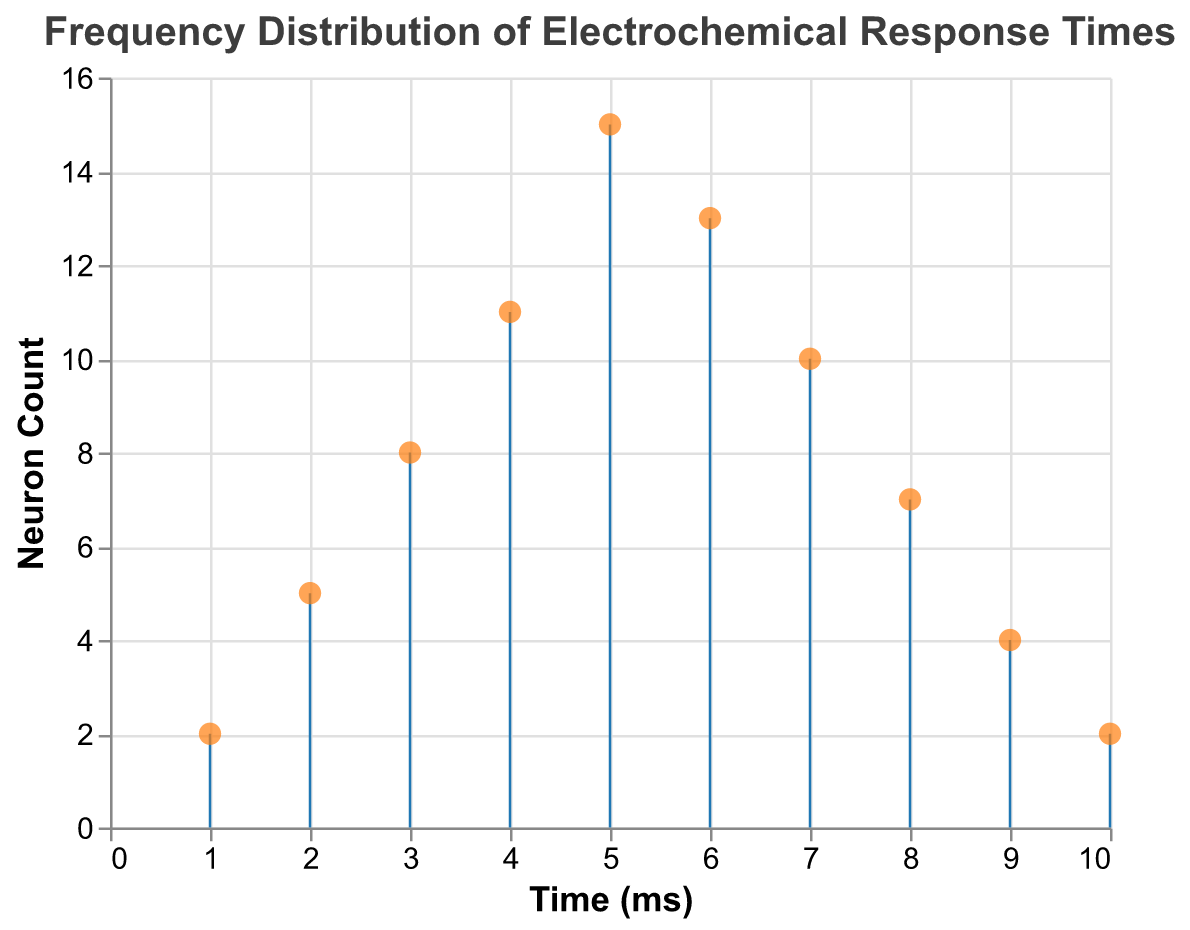What is the title of the plot? The title of the plot is prominently displayed at the top and reads "Frequency Distribution of Electrochemical Response Times".
Answer: Frequency Distribution of Electrochemical Response Times How many data points are plotted? By counting the data points represented by the colored markers on the plot, there are ten data points.
Answer: Ten What is the electrochemical response time with the highest neuron count? The data point with the highest count has a value of 15 neurons, which corresponds to a time of 5 ms.
Answer: 5 ms How does the neuron count change from 4 ms to 5 ms? At 4 ms, the neuron count is 11, and it increases to 15 at 5 ms. The difference is 15 - 11 = 4.
Answer: Increases by 4 What is the total count of neurons from 1 ms to 5 ms? Sum the counts from 1 ms to 5 ms: 2 (at 1 ms) + 5 (at 2 ms) + 8 (at 3 ms) + 11 (at 4 ms) + 15 (at 5 ms) = 41.
Answer: 41 What is the average neuron count for the last three time intervals (8 ms, 9 ms, 10 ms)? Add the counts for 8 ms, 9 ms, and 10 ms and divide by 3: (7 + 4 + 2) / 3 = 13 / 3 ≈ 4.33.
Answer: ≈ 4.33 Which time interval shows the steepest decline in neuron count? The steepest decline occurs between 6 ms and 7 ms, with neuron counts dropping from 13 to 10, a decline of 3.
Answer: Between 6 ms and 7 ms At what time(s) do the neuron counts reach the same value? The counts are 2 at both 1 ms and 10 ms.
Answer: 1 ms and 10 ms What is the median count of neurons? The neuron counts in ascending order are: 2, 2, 4, 5, 7, 8, 10, 11, 13, 15. The median value, being the 5th and 6th values, is (7+8)/2 = 7.5.
Answer: 7.5 Describe the trend of the neuron counts from 1 ms to 10 ms. The neuron count increases from 1 ms to peak at 5 ms, then generally declines towards 10 ms.
Answer: Increases to 5 ms, then declines 